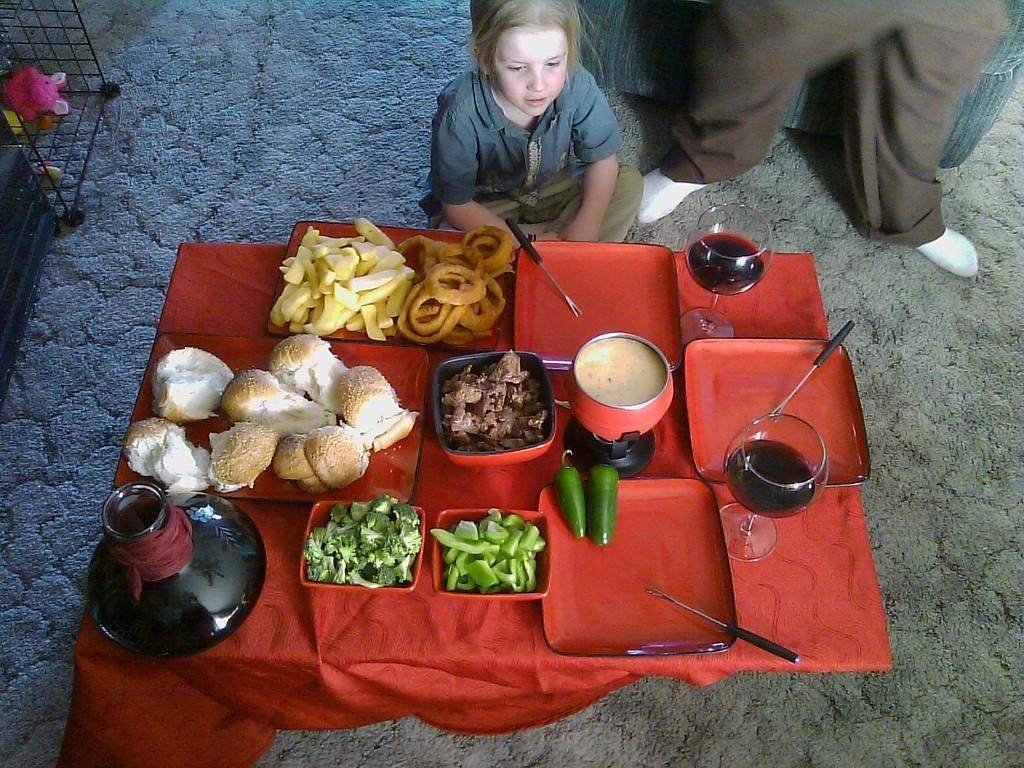What is the girl in the image doing? The girl is sitting in the image. What is in front of the girl? There is a table in front of the girl. What type of food can be seen on the table? There are bowls with broccoli and capsicum on the table, as well as chili. What else is on the table besides food? There are wine glasses on the table. What type of punishment is being given to the girl in the image? There is no indication of punishment in the image; the girl is simply sitting at a table with food and wine glasses. What word is being spelled out by the food on the table? There is no word being spelled out by the food on the table; the food items are simply arranged in bowls. 